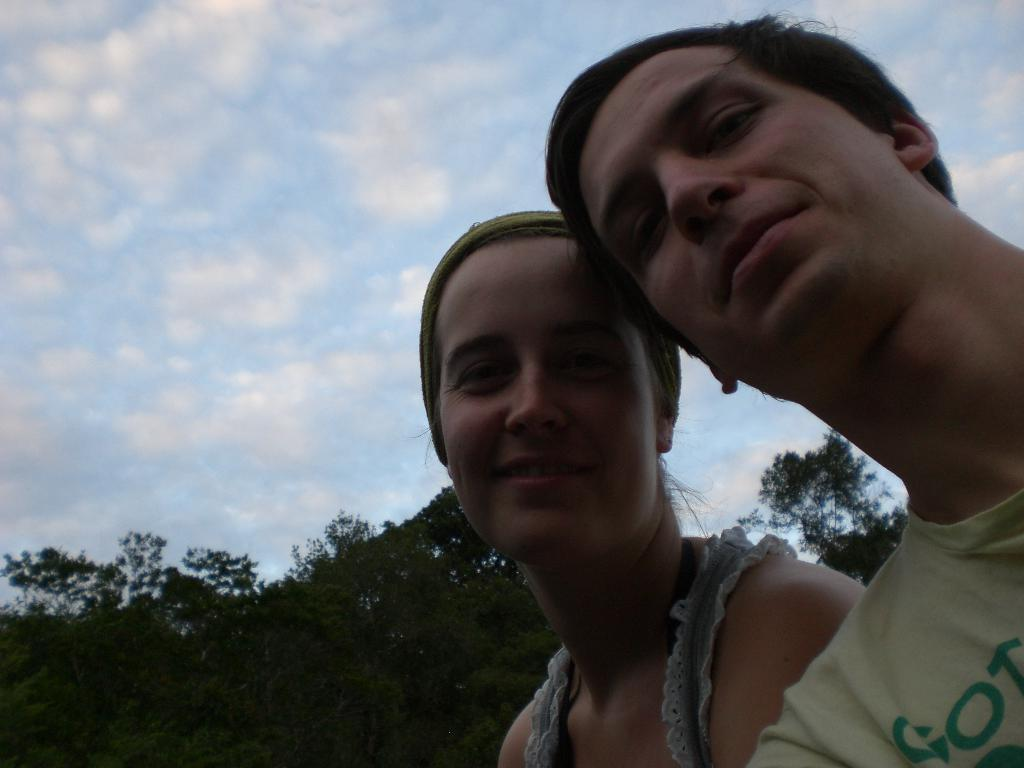How many people are present in the image? There are two persons in the image. What type of natural elements can be seen in the image? There are trees in the image. What is visible in the sky in the image? There are clouds in the sky. What type of notebook is being used by the rat in the image? There is no rat or notebook present in the image. 